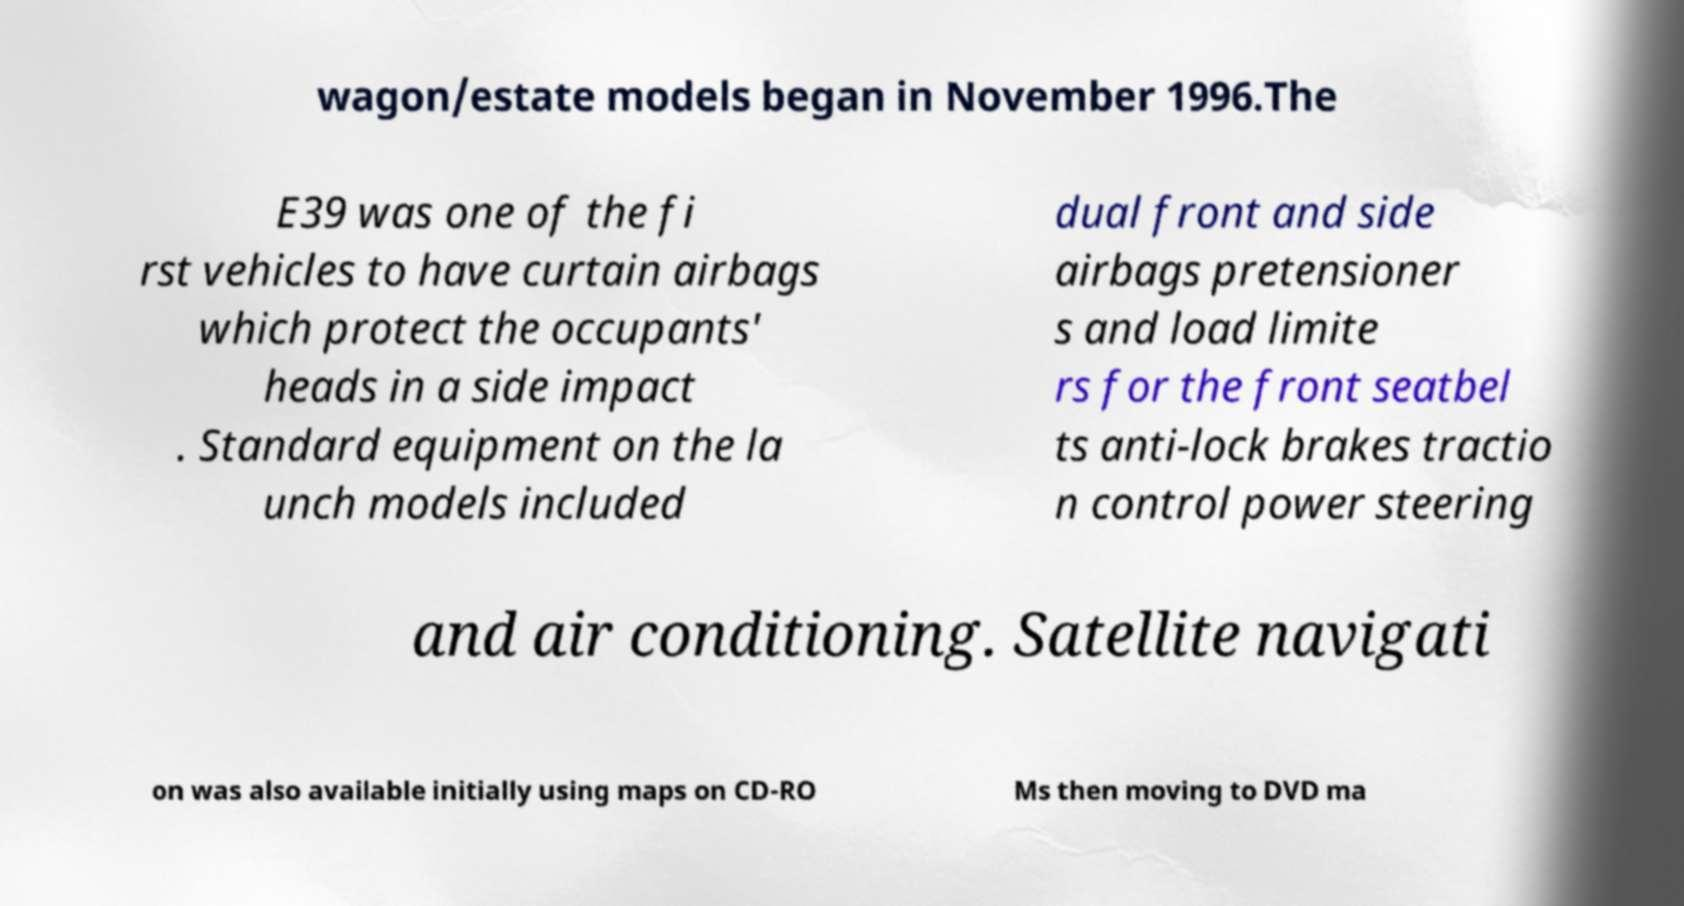Can you accurately transcribe the text from the provided image for me? wagon/estate models began in November 1996.The E39 was one of the fi rst vehicles to have curtain airbags which protect the occupants' heads in a side impact . Standard equipment on the la unch models included dual front and side airbags pretensioner s and load limite rs for the front seatbel ts anti-lock brakes tractio n control power steering and air conditioning. Satellite navigati on was also available initially using maps on CD-RO Ms then moving to DVD ma 